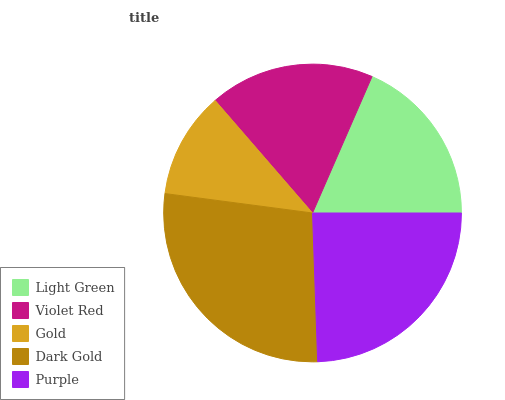Is Gold the minimum?
Answer yes or no. Yes. Is Dark Gold the maximum?
Answer yes or no. Yes. Is Violet Red the minimum?
Answer yes or no. No. Is Violet Red the maximum?
Answer yes or no. No. Is Light Green greater than Violet Red?
Answer yes or no. Yes. Is Violet Red less than Light Green?
Answer yes or no. Yes. Is Violet Red greater than Light Green?
Answer yes or no. No. Is Light Green less than Violet Red?
Answer yes or no. No. Is Light Green the high median?
Answer yes or no. Yes. Is Light Green the low median?
Answer yes or no. Yes. Is Violet Red the high median?
Answer yes or no. No. Is Purple the low median?
Answer yes or no. No. 